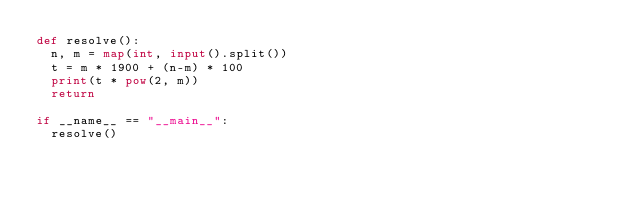<code> <loc_0><loc_0><loc_500><loc_500><_Python_>def resolve():
  n, m = map(int, input().split())
  t = m * 1900 + (n-m) * 100
  print(t * pow(2, m))
  return

if __name__ == "__main__":
  resolve()
</code> 